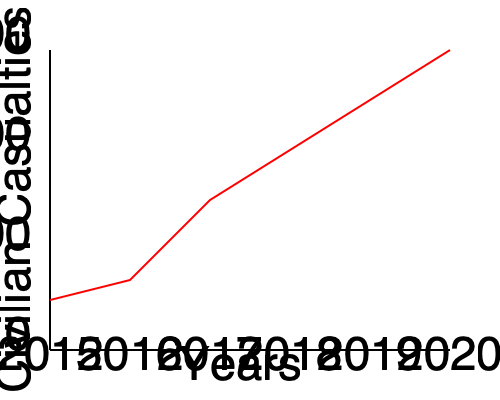Analyze the line graph depicting changes in civilian casualties from 2015 to 2020 in a specific conflict region. What trend does the graph show, and what factors might have contributed to this trend based on your experience as a peace activist with knowledge of local conditions? To analyze the graph and identify potential factors contributing to the trend, let's follow these steps:

1. Observe the overall trend:
   The graph shows a consistent decrease in civilian casualties from 2015 to 2020.

2. Quantify the change:
   - 2015: Approximately 1250 casualties
   - 2020: Approximately 250 casualties
   This represents a reduction of about 80% over five years.

3. Identify potential contributing factors:
   a) Increased peace-building efforts: As a peace activist, you may have observed or participated in growing initiatives to promote dialogue and reconciliation.
   
   b) Improved conflict resolution mechanisms: Local or international organizations might have implemented more effective ways to address disputes without violence.
   
   c) Enhanced civilian protection measures: Military forces or peacekeeping units may have adopted stricter rules of engagement or better technologies to avoid civilian harm.
   
   d) Shifts in conflict dynamics: The nature of the conflict might have changed, moving away from populated areas or becoming less intense overall.
   
   e) Improved early warning systems: Better communication and alert systems may have helped civilians avoid dangerous areas or situations.
   
   f) Economic development: Improved economic conditions could have reduced motivations for violence or provided alternatives to conflict.

4. Consider local context:
   As someone with knowledge of local conditions, you might be aware of specific peace agreements, changes in leadership, or other regional factors that align with this downward trend in casualties.

5. Acknowledge potential limitations:
   It's important to note that while the trend is positive, there are still civilian casualties occurring, indicating ongoing challenges in fully protecting civilian populations in conflict zones.
Answer: Decreasing trend in civilian casualties, likely due to improved peace-building efforts, protection measures, and conflict resolution mechanisms, aligned with local peace initiatives and changing conflict dynamics. 